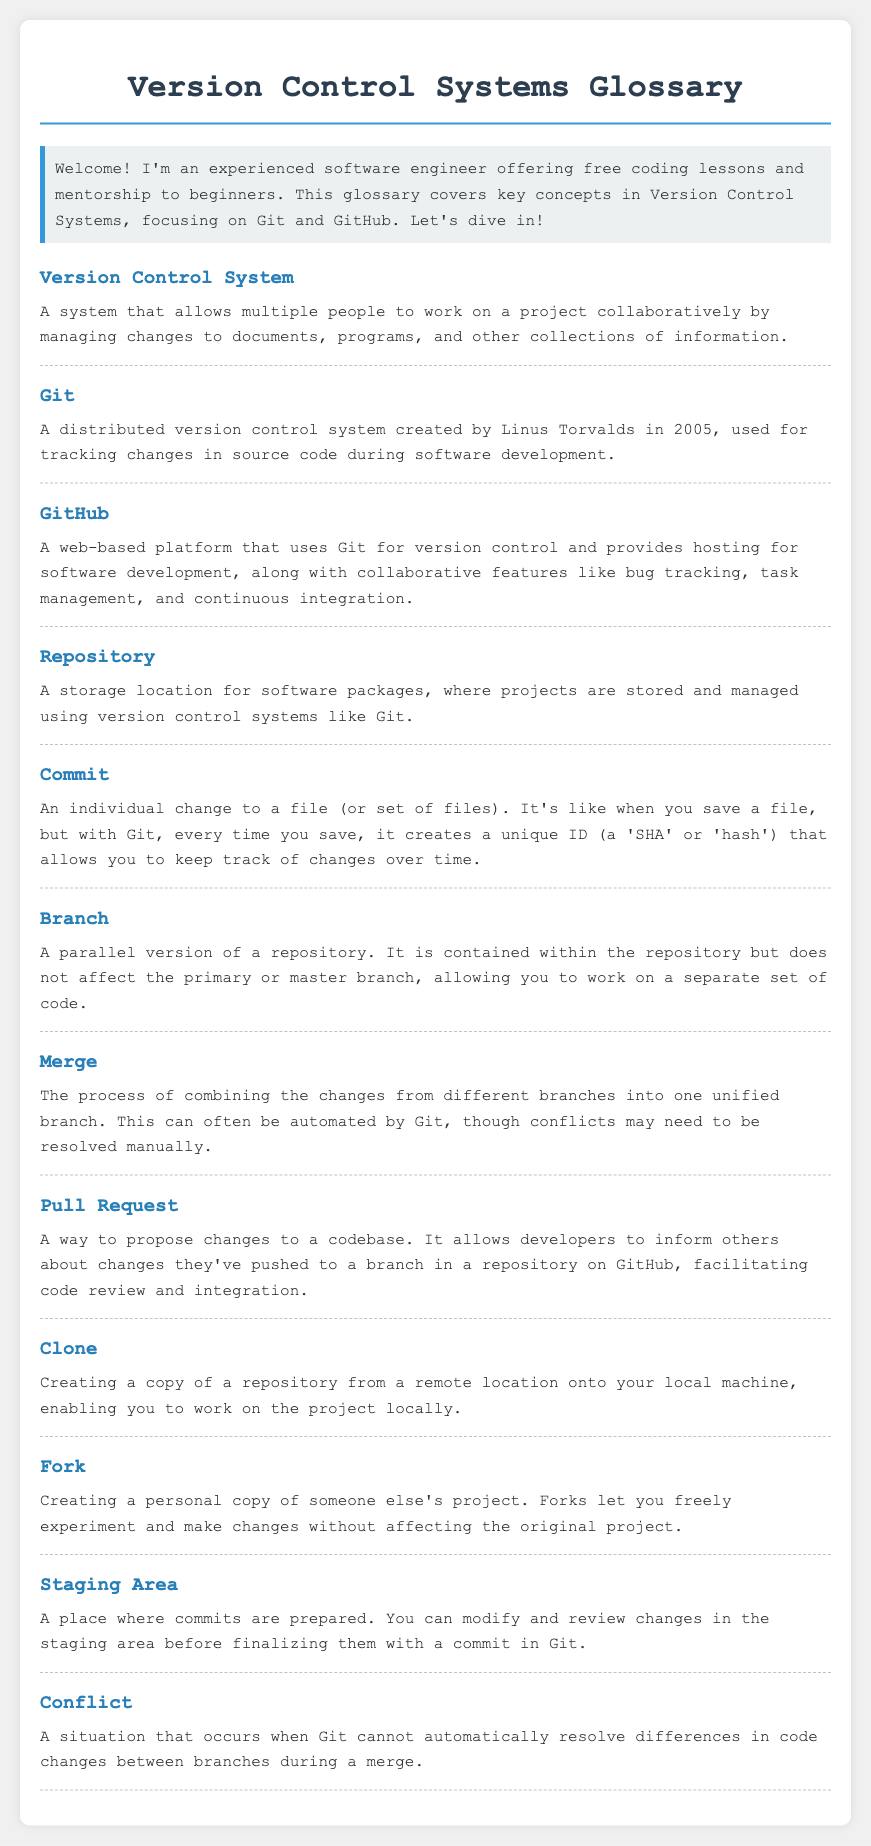What is a Version Control System? A Version Control System allows multiple people to work on a project collaboratively by managing changes to documents, programs, and other collections of information.
Answer: A system that allows multiple people to work on a project collaboratively What year was Git created? The document states that Git was created in 2005.
Answer: 2005 What is a Pull Request? A Pull Request is a way to propose changes to a codebase on GitHub, facilitating code review and integration.
Answer: A way to propose changes to a codebase What does merging do in Git? Merging is the process of combining changes from different branches into one unified branch.
Answer: Combining changes from different branches What is the purpose of the Staging Area? The Staging Area is where commits are prepared before finalizing them in Git.
Answer: A place where commits are prepared What happens during a Conflict in Git? A Conflict occurs when Git cannot automatically resolve differences in code changes during a merge.
Answer: A situation when Git cannot automatically resolve differences 